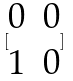<formula> <loc_0><loc_0><loc_500><loc_500>[ \begin{matrix} 0 & 0 \\ 1 & 0 \end{matrix} ]</formula> 